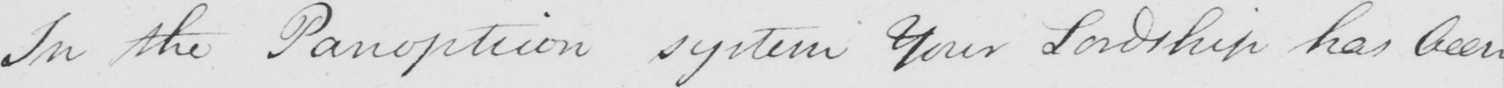Transcribe the text shown in this historical manuscript line. In the Panopticon system Your Lordship has been 